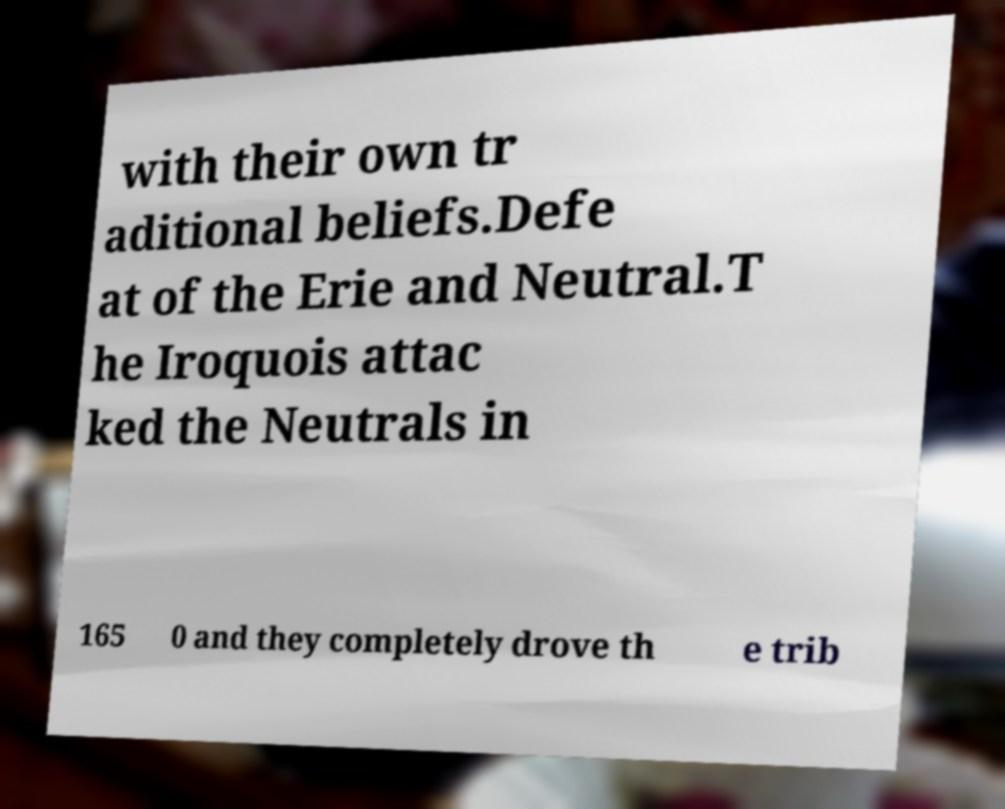Could you extract and type out the text from this image? with their own tr aditional beliefs.Defe at of the Erie and Neutral.T he Iroquois attac ked the Neutrals in 165 0 and they completely drove th e trib 